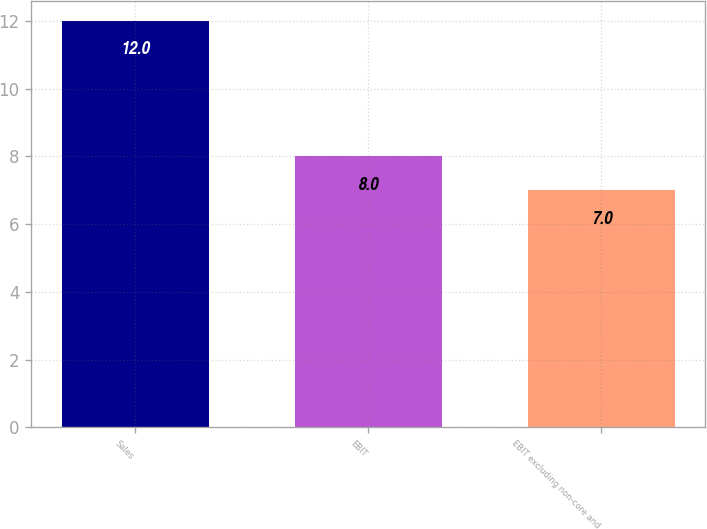<chart> <loc_0><loc_0><loc_500><loc_500><bar_chart><fcel>Sales<fcel>EBIT<fcel>EBIT excluding non-core and<nl><fcel>12<fcel>8<fcel>7<nl></chart> 